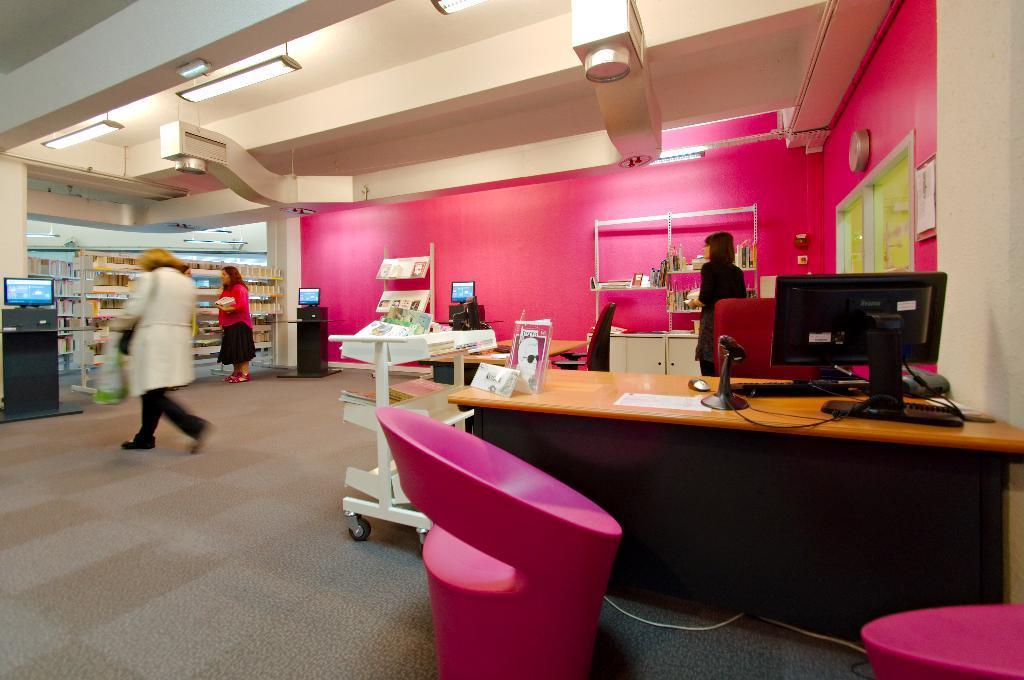In one or two sentences, can you explain what this image depicts? In this image we can see inside of a building. There are many books placed on the racks. There are few chairs and tables in the image. There are few computers in the image. There are many lights attached to the roof in the image. There are few objects on the wall. There are few objects placed on the tables. 